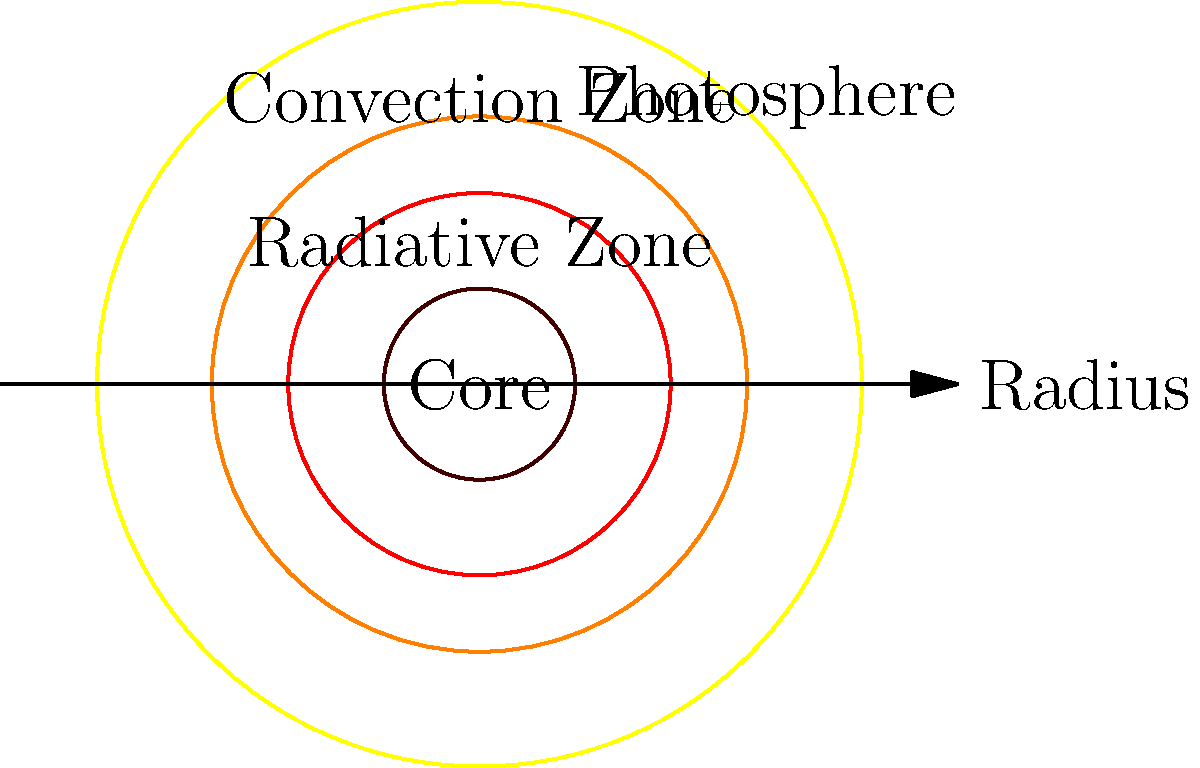As an advertising executive familiar with market segmentation, you understand the importance of layered structures. In the context of a star like our Sun, which layer is responsible for the visible surface we observe and is often the focus of solar imaging campaigns? To answer this question, let's break down the structure of a star like our Sun:

1. Core: The innermost layer where nuclear fusion occurs, generating the star's energy.

2. Radiative Zone: The middle layer where energy is transported outward through radiation.

3. Convection Zone: The outer layer where energy is transported through convection currents.

4. Photosphere: The visible "surface" of the star.

5. Atmosphere (not shown in the diagram): Consists of the chromosphere and corona, extending beyond the photosphere.

The key to answering this question lies in understanding that the photosphere is the layer we actually see when we look at the Sun or other stars. It's the lowest layer of the star's atmosphere and is often referred to as the star's surface.

In the context of solar imaging and observation campaigns:

- The photosphere is the primary focus because it's the visible layer.
- It's where we observe phenomena like sunspots and solar granulation.
- Most of the light we see from the Sun comes from this layer.
- The photosphere is also the layer used to define the Sun's "edge" in most contexts.

Therefore, the photosphere is the layer responsible for the visible surface we observe and is often the focus of solar imaging campaigns.
Answer: Photosphere 